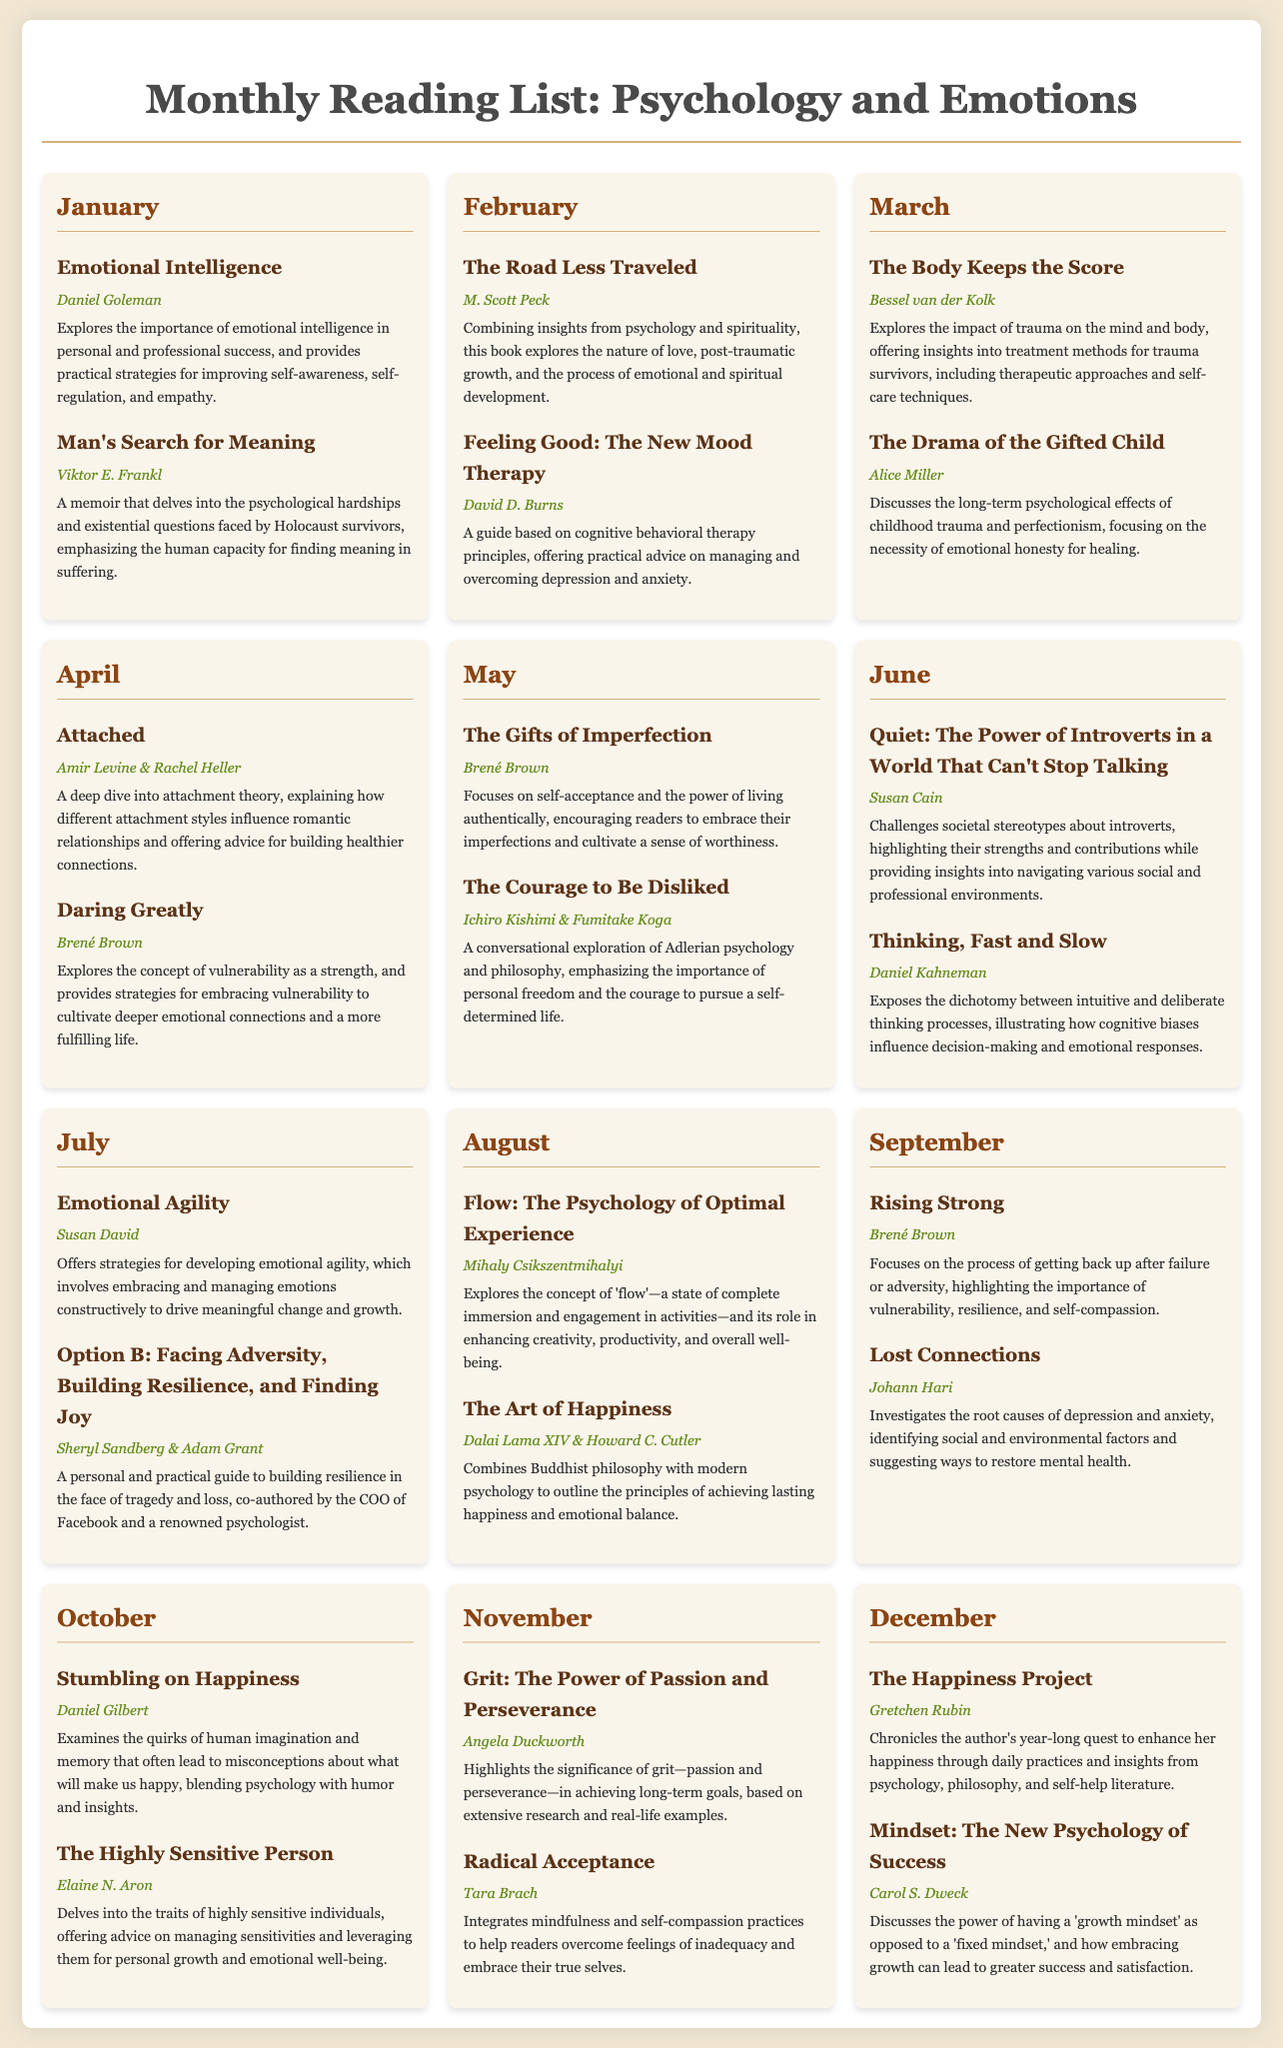What is the title of the book by Daniel Goleman? The title of the book is mentioned in January's section, focusing on emotional intelligence.
Answer: Emotional Intelligence Who authored "Man's Search for Meaning"? The author is listed next to the book title in January, which explores existential questions.
Answer: Viktor E. Frankl What month features "The Road Less Traveled"? This book is found in February's section of the reading list.
Answer: February How many books are listed in the month of March? The document indicates two books are listed under March.
Answer: 2 What theme does "The Body Keeps the Score" focus on? The theme is described in March and pertains to the impact of trauma.
Answer: Trauma Which author has multiple books on the list? The document specifies that Brené Brown has more than one book featured.
Answer: Brené Brown What is the last book listed in December? This book's title is found in December's section of the calendar.
Answer: Mindset: The New Psychology of Success In which month is "Lost Connections" featured? The month is indicated in September according to the document.
Answer: September How many books are attributed to Daniel Kahneman? The entry for June shows there is one book written by Daniel Kahneman.
Answer: 1 